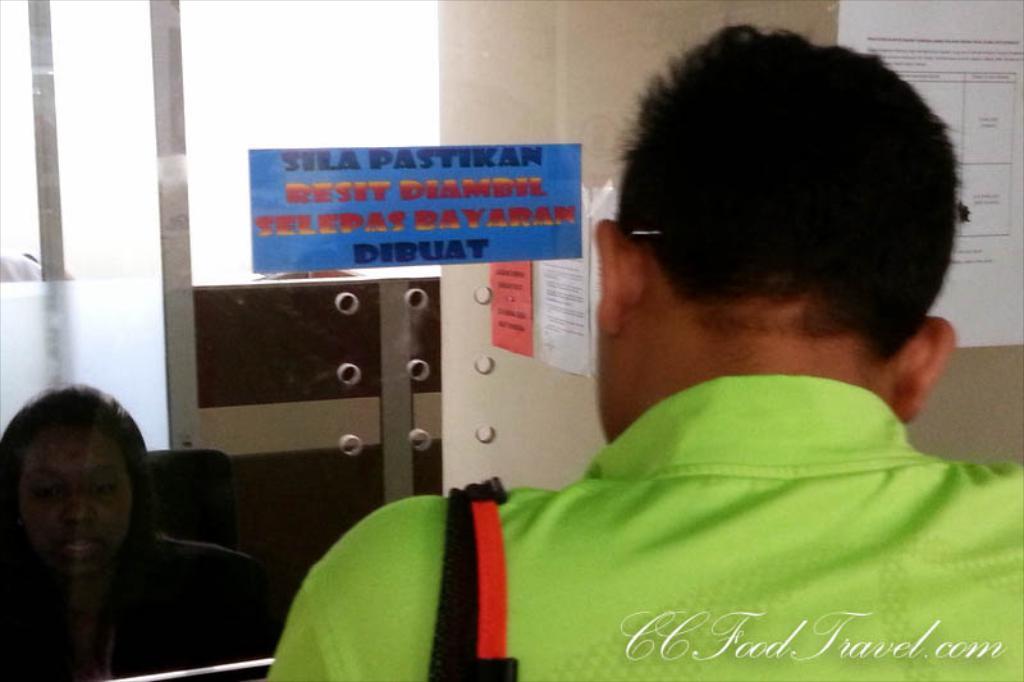Please provide a concise description of this image. In this image there is a person with green shirt. In the background there is a woman sitting on the chair. There are also papers attached to the glass windows and some papers are attached to the wall. Logo is also visible. 